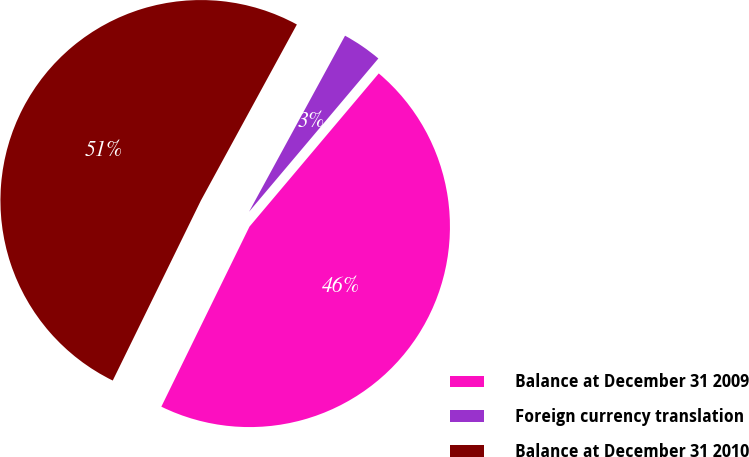<chart> <loc_0><loc_0><loc_500><loc_500><pie_chart><fcel>Balance at December 31 2009<fcel>Foreign currency translation<fcel>Balance at December 31 2010<nl><fcel>46.09%<fcel>3.21%<fcel>50.7%<nl></chart> 